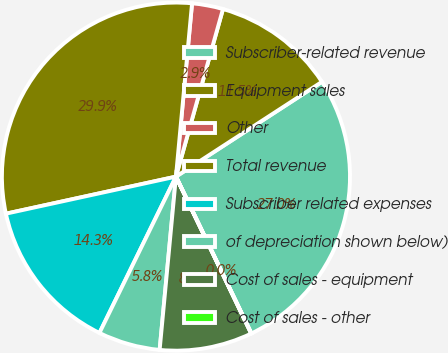Convert chart. <chart><loc_0><loc_0><loc_500><loc_500><pie_chart><fcel>Subscriber-related revenue<fcel>Equipment sales<fcel>Other<fcel>Total revenue<fcel>Subscriber related expenses<fcel>of depreciation shown below)<fcel>Cost of sales - equipment<fcel>Cost of sales - other<nl><fcel>27.03%<fcel>11.48%<fcel>2.88%<fcel>29.89%<fcel>14.34%<fcel>5.75%<fcel>8.61%<fcel>0.02%<nl></chart> 